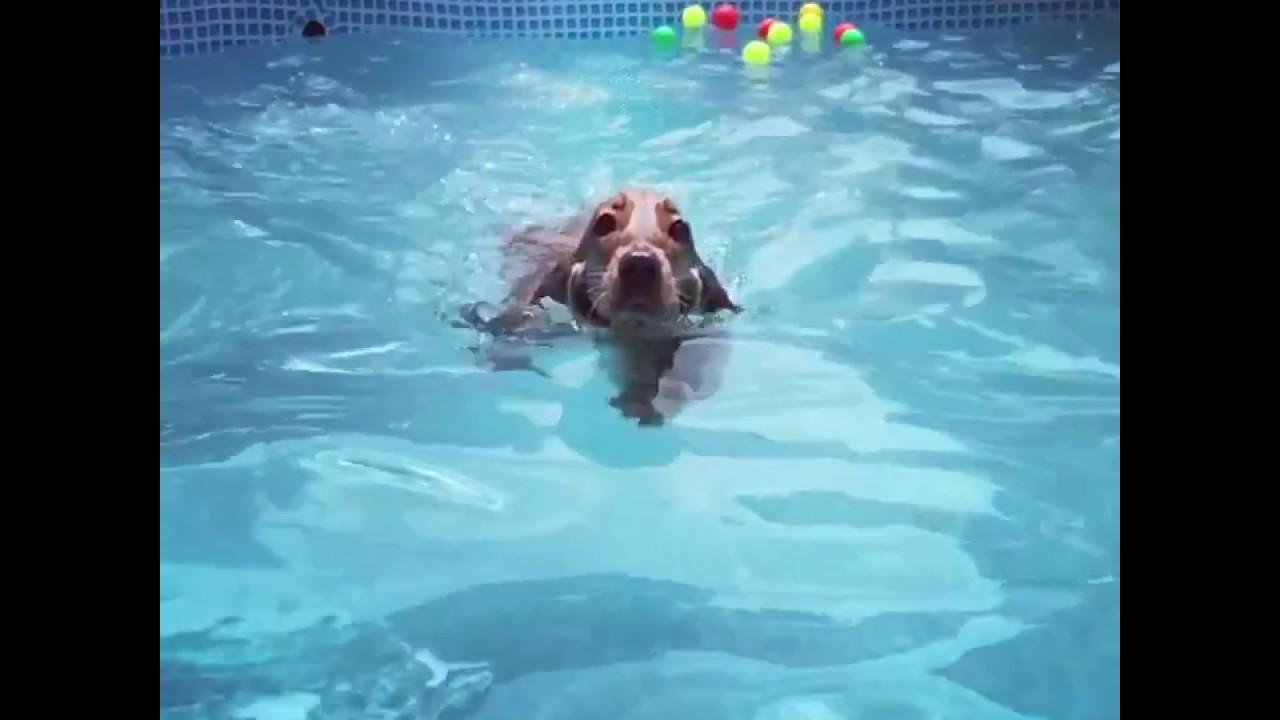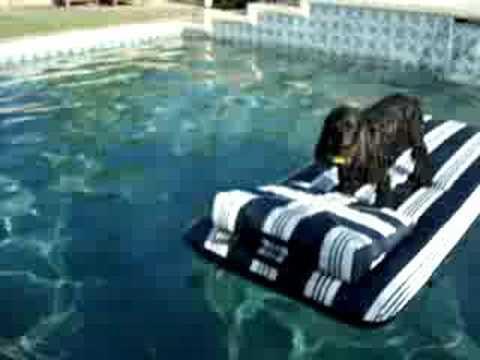The first image is the image on the left, the second image is the image on the right. Given the left and right images, does the statement "One of the dogs is using a floatation device in the pool." hold true? Answer yes or no. Yes. The first image is the image on the left, the second image is the image on the right. Evaluate the accuracy of this statement regarding the images: "A dog is in mid-leap over the blue water of a manmade pool.". Is it true? Answer yes or no. No. 